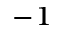<formula> <loc_0><loc_0><loc_500><loc_500>^ { - 1 }</formula> 